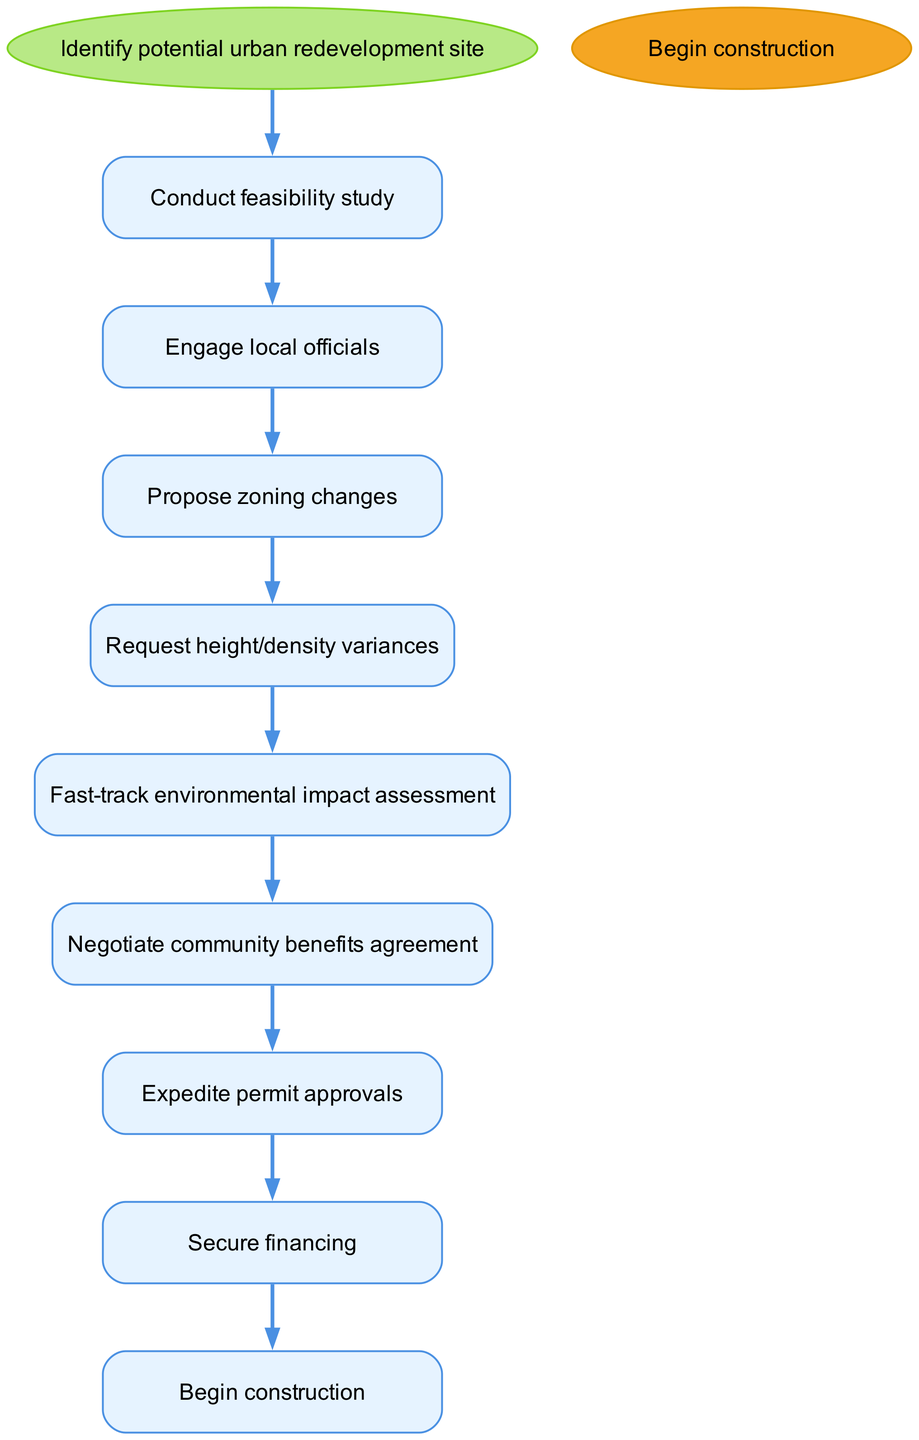What is the first step in the pathway? The pathway starts with the node labeled "Identify potential urban redevelopment site," which marks the initiation of the process.
Answer: Identify potential urban redevelopment site How many steps are there in total? The diagram lists eight distinct steps in the pathway, transitioning from the identification of the site to the commencement of construction.
Answer: 8 What follows after "Engage local officials"? The step immediately following "Engage local officials" in the pathway is "Propose zoning changes," indicating what the next action will be.
Answer: Propose zoning changes What is the last action before "Begin construction"? Before reaching the endpoint "Begin construction," the final step taken is "Secure financing," which indicates that obtaining funding is crucial prior to starting the construction phase.
Answer: Secure financing Which step requires negotiation with the community? "Negotiate community benefits agreement" is the step that directly involves discussions and compromises with the local community regarding the benefits they will receive from the redevelopment project.
Answer: Negotiate community benefits agreement Is "Fast-track environmental impact assessment" a prerequisite for securing financing? No, "Fast-track environmental impact assessment" must occur prior to "Secure financing," indicating it is an essential step that needs to be completed first before moving on to securing funding.
Answer: No How is the pathway structured in terms of progression? The clinical pathway is structured sequentially with each step leading to the next in a logical order, demonstrating a clear path from site identification to project commencement.
Answer: Sequentially Which step directly leads to permit approvals? "Expedite permit approvals" is the step that directly follows "Negotiate community benefits agreement," indicating that these are necessary steps towards acquiring the required permissions for construction.
Answer: Expedite permit approvals 